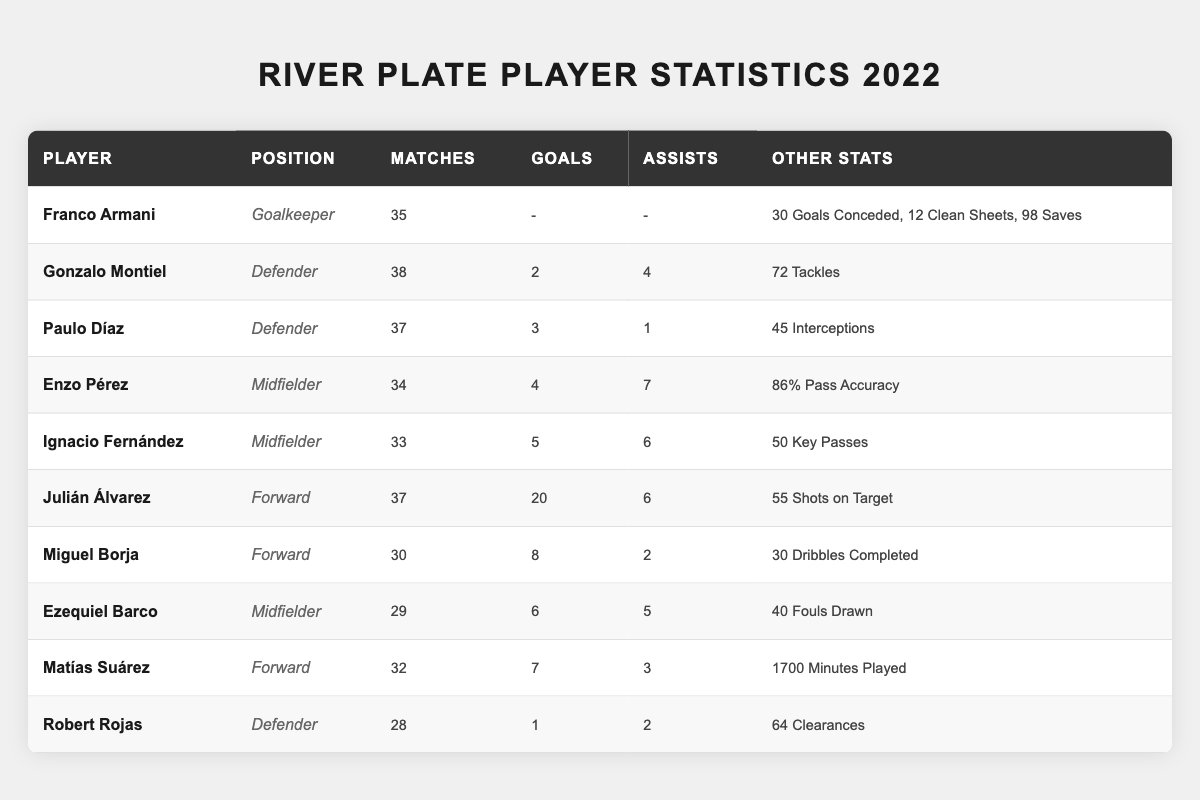What position did Julián Álvarez play? The table indicates Julián Álvarez's position as a "Forward" in the respective column for player positions.
Answer: Forward How many clean sheets did Franco Armani have? The table shows that Franco Armani had 12 clean sheets, stated in the "Other Stats" column.
Answer: 12 Who scored the most goals for River Plate in the 2022 season? Julián Álvarez scored the most goals, with a total of 20 goals according to the goals column.
Answer: Julián Álvarez What is the total number of matches played by the defenders listed? Adding the matches played by all defenders: 38 (Montiel) + 37 (Díaz) + 28 (Rojas) = 103 matches.
Answer: 103 Did Ezequiel Barco score more goals than Miguel Borja? Ezequiel Barco scored 6 goals while Miguel Borja scored 8 goals, which means Barco did not score more goals.
Answer: No What was the average number of goals scored by midfielders? The total goals scored by midfielders (Enzo Pérez: 4, Ignacio Fernández: 5, Ezequiel Barco: 6) amounts to 15. There are 3 midfielders, therefore the average is 15/3 = 5.
Answer: 5 How many assists did Ignacio Fernández contribute? The table indicates that Ignacio Fernández provided 6 assists as shown in the assists column.
Answer: 6 Who had the lowest number of matches played among the players listed? By reviewing the matches played column, Robert Rojas has the lowest with 28 matches played.
Answer: Robert Rojas How many more goals did Julián Álvarez score compared to Matías Suárez? Julián Álvarez scored 20 goals and Matías Suárez scored 7 goals. The difference is 20 - 7 = 13 goals more from Álvarez.
Answer: 13 How many total tackles were made by Gonzalo Montiel and Paulo Díaz combined? Gonzalo Montiel made 72 tackles and Paulo Díaz did not have tackles listed, so the total is 72 + 0 = 72 tackles.
Answer: 72 